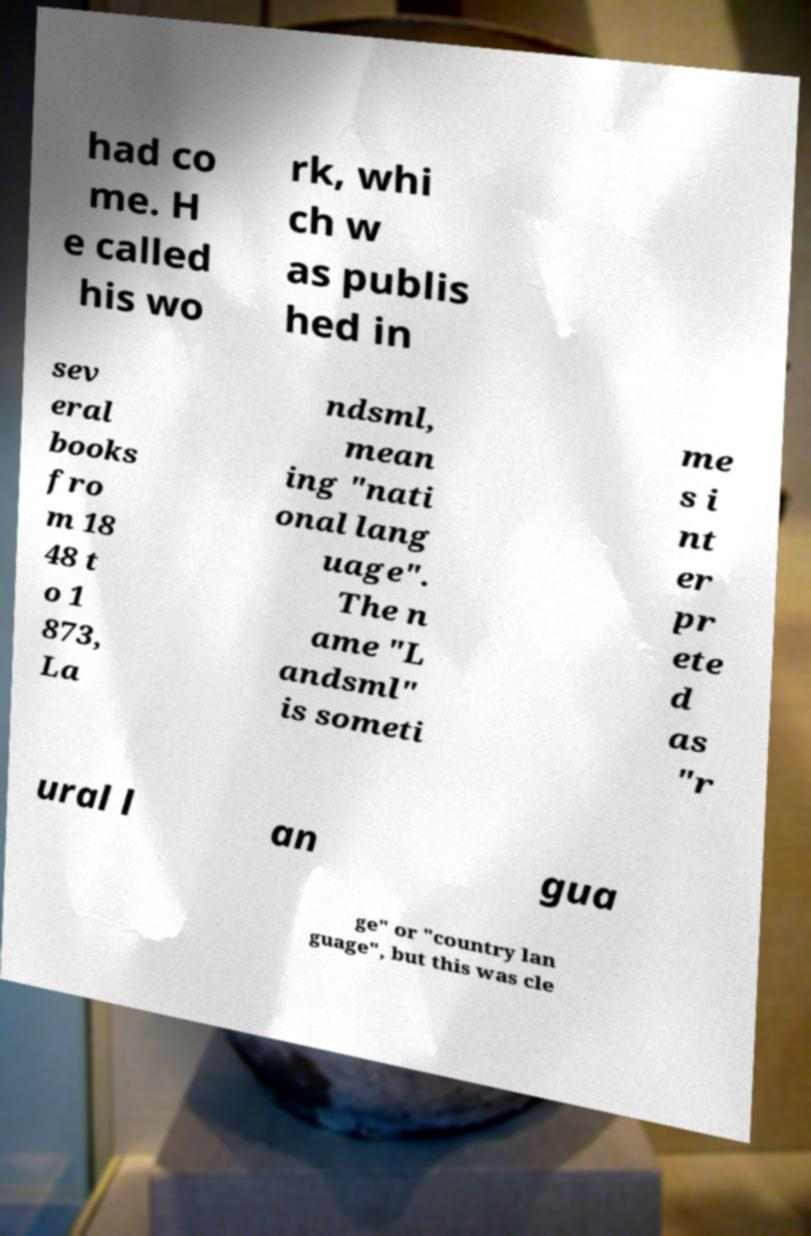For documentation purposes, I need the text within this image transcribed. Could you provide that? had co me. H e called his wo rk, whi ch w as publis hed in sev eral books fro m 18 48 t o 1 873, La ndsml, mean ing "nati onal lang uage". The n ame "L andsml" is someti me s i nt er pr ete d as "r ural l an gua ge" or "country lan guage", but this was cle 